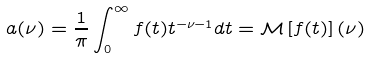Convert formula to latex. <formula><loc_0><loc_0><loc_500><loc_500>a ( \nu ) = \frac { 1 } { \pi } \int _ { 0 } ^ { \infty } f ( t ) t ^ { - \nu - 1 } d t = \mathcal { M } \left [ f ( t ) \right ] ( \nu )</formula> 